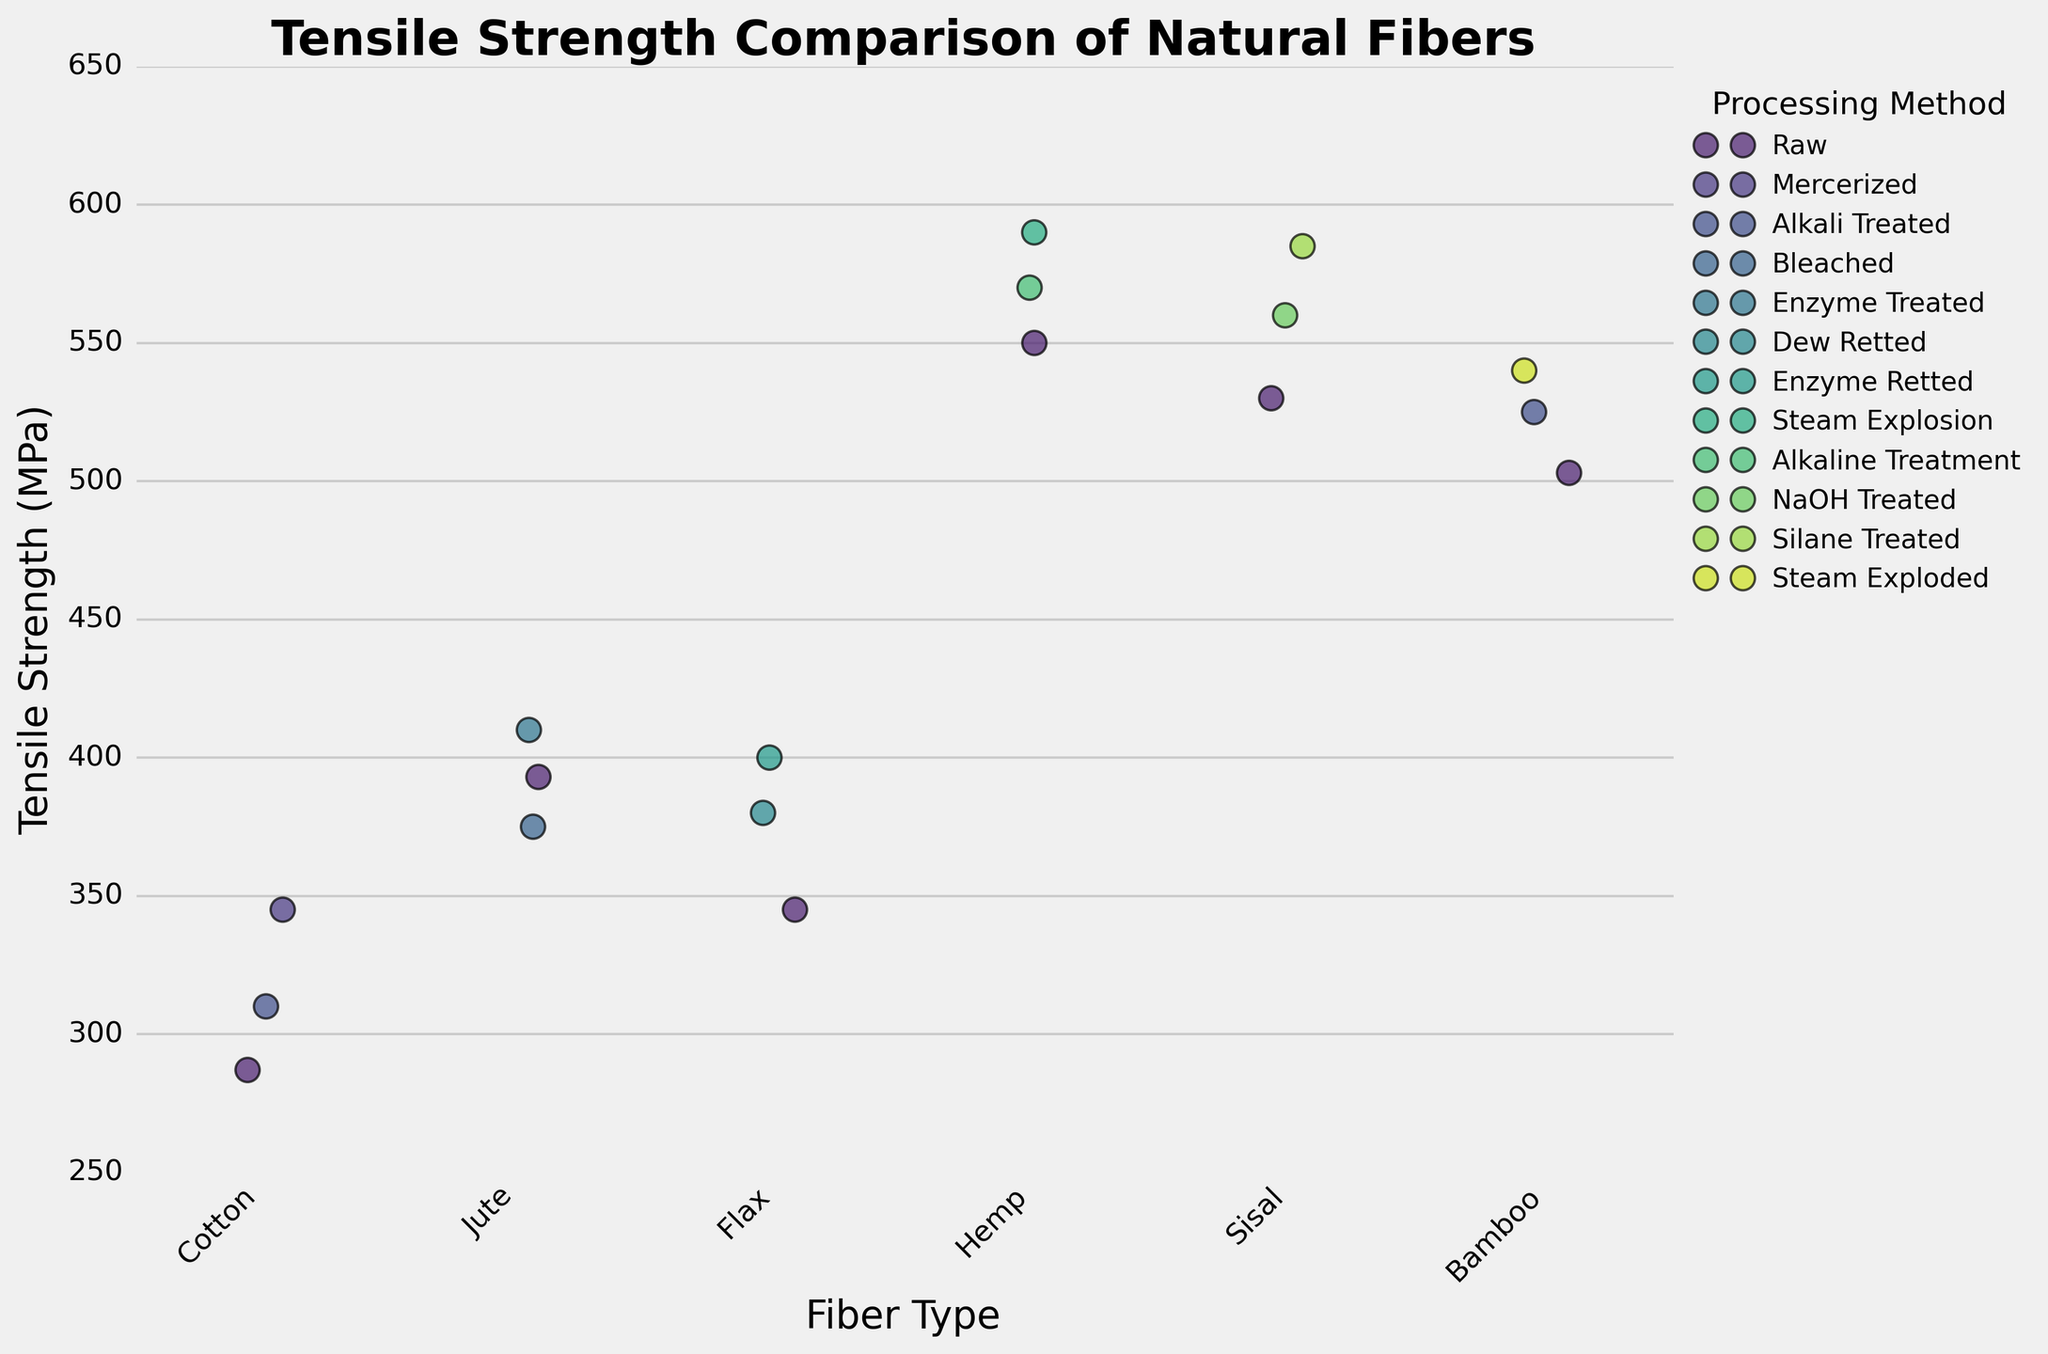What's the title of the plot? The title is usually located at the top of the plot. Here, it reads 'Tensile Strength Comparison of Natural Fibers'.
Answer: Tensile Strength Comparison of Natural Fibers Which fiber type has the highest overall tensile strength in any processing method? To determine the highest tensile strength, look for the highest data point in the plot. For Hemp with Steam Explosion processing method, it reaches 590 MPa, which is the highest tensile strength shown in the plot.
Answer: Hemp (Steam Explosion) How does the tensile strength of Raw Jute compare to that of Raw Cotton? Locate the data points for Raw Jute and Raw Cotton. Raw Jute has a tensile strength of 393 MPa, while Raw Cotton has 287 MPa. This indicates that Raw Jute has a higher tensile strength than Raw Cotton.
Answer: Raw Jute is stronger Which fiber processing method generally increases tensile strength the most for the fibers provided? Look at the tensile strength values for each fiber under different processing methods. Most fibers show the highest tensile strengths under treatments like "Steam Explosion" for Hemp, "Silane Treated" for Sisal, etc., suggesting that these specialized treatments generally improve tensile strength more than being Raw.
Answer: Specialized treatments (e.g., Steam Explosion, Silane Treated) What is the tensile strength range for Cotton under different processing methods? Locate all the Cotton data points. They are 287 MPa for Raw, 345 MPa for Mercerized, and 310 MPa for Alkali Treated. The range is the difference between the highest and lowest values.
Answer: 58 MPa (345 - 287) How does the tensile strength of Bamboo change with different processing methods? Examine the data points for Bamboo: Raw (503 MPa), Steam Exploded (540 MPa), and Alkali Treated (525 MPa). The tensile strength increases from Raw to Steam Exploded and slightly decreases with Alkali Treated but is still higher than Raw.
Answer: It increases with processing Which fiber exhibits the least variation in tensile strength across different methods? Compare the tensile strength values across different methods for each fiber. Cotton shows the least variation: Raw (287 MPa), Mercerized (345 MPa), Alkali Treated (310 MPa).
Answer: Cotton 